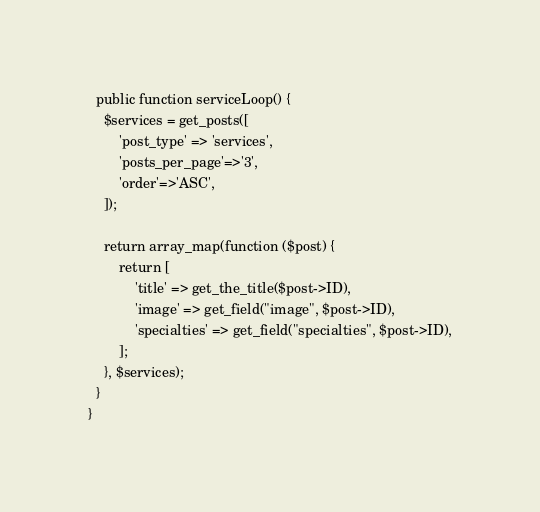Convert code to text. <code><loc_0><loc_0><loc_500><loc_500><_PHP_>  public function serviceLoop() {
    $services = get_posts([
        'post_type' => 'services',
        'posts_per_page'=>'3',
        'order'=>'ASC',
    ]);

    return array_map(function ($post) {
        return [
            'title' => get_the_title($post->ID),
            'image' => get_field("image", $post->ID),
            'specialties' => get_field("specialties", $post->ID),
        ];
    }, $services);
  }
}
</code> 